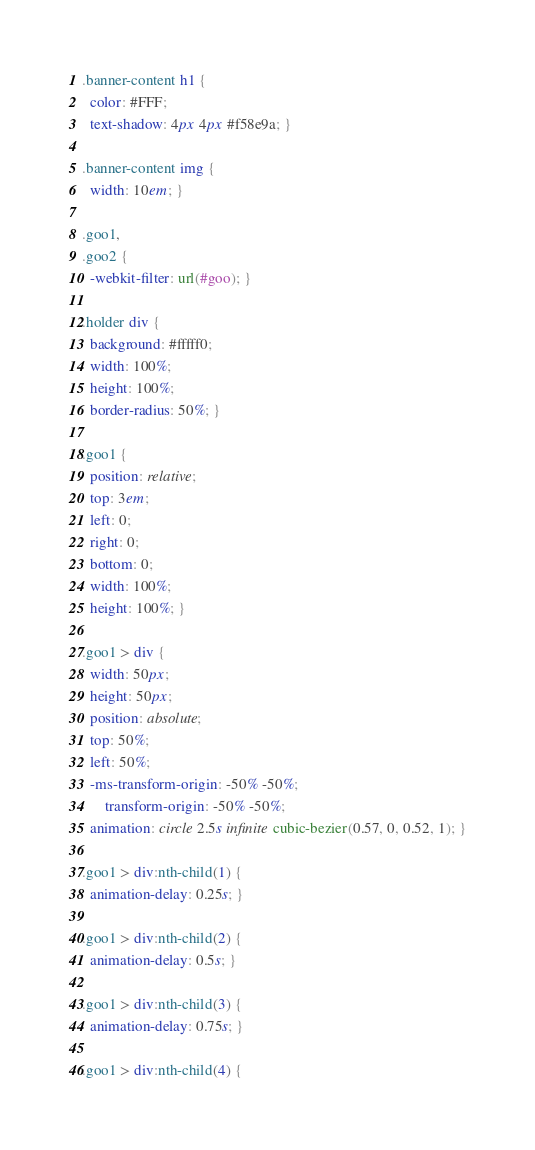<code> <loc_0><loc_0><loc_500><loc_500><_CSS_>.banner-content h1 {
  color: #FFF;
  text-shadow: 4px 4px #f58e9a; }

.banner-content img {
  width: 10em; }

.goo1,
.goo2 {
  -webkit-filter: url(#goo); }

.holder div {
  background: #fffff0;
  width: 100%;
  height: 100%;
  border-radius: 50%; }

.goo1 {
  position: relative;
  top: 3em;
  left: 0;
  right: 0;
  bottom: 0;
  width: 100%;
  height: 100%; }

.goo1 > div {
  width: 50px;
  height: 50px;
  position: absolute;
  top: 50%;
  left: 50%;
  -ms-transform-origin: -50% -50%;
      transform-origin: -50% -50%;
  animation: circle 2.5s infinite cubic-bezier(0.57, 0, 0.52, 1); }

.goo1 > div:nth-child(1) {
  animation-delay: 0.25s; }

.goo1 > div:nth-child(2) {
  animation-delay: 0.5s; }

.goo1 > div:nth-child(3) {
  animation-delay: 0.75s; }

.goo1 > div:nth-child(4) {</code> 